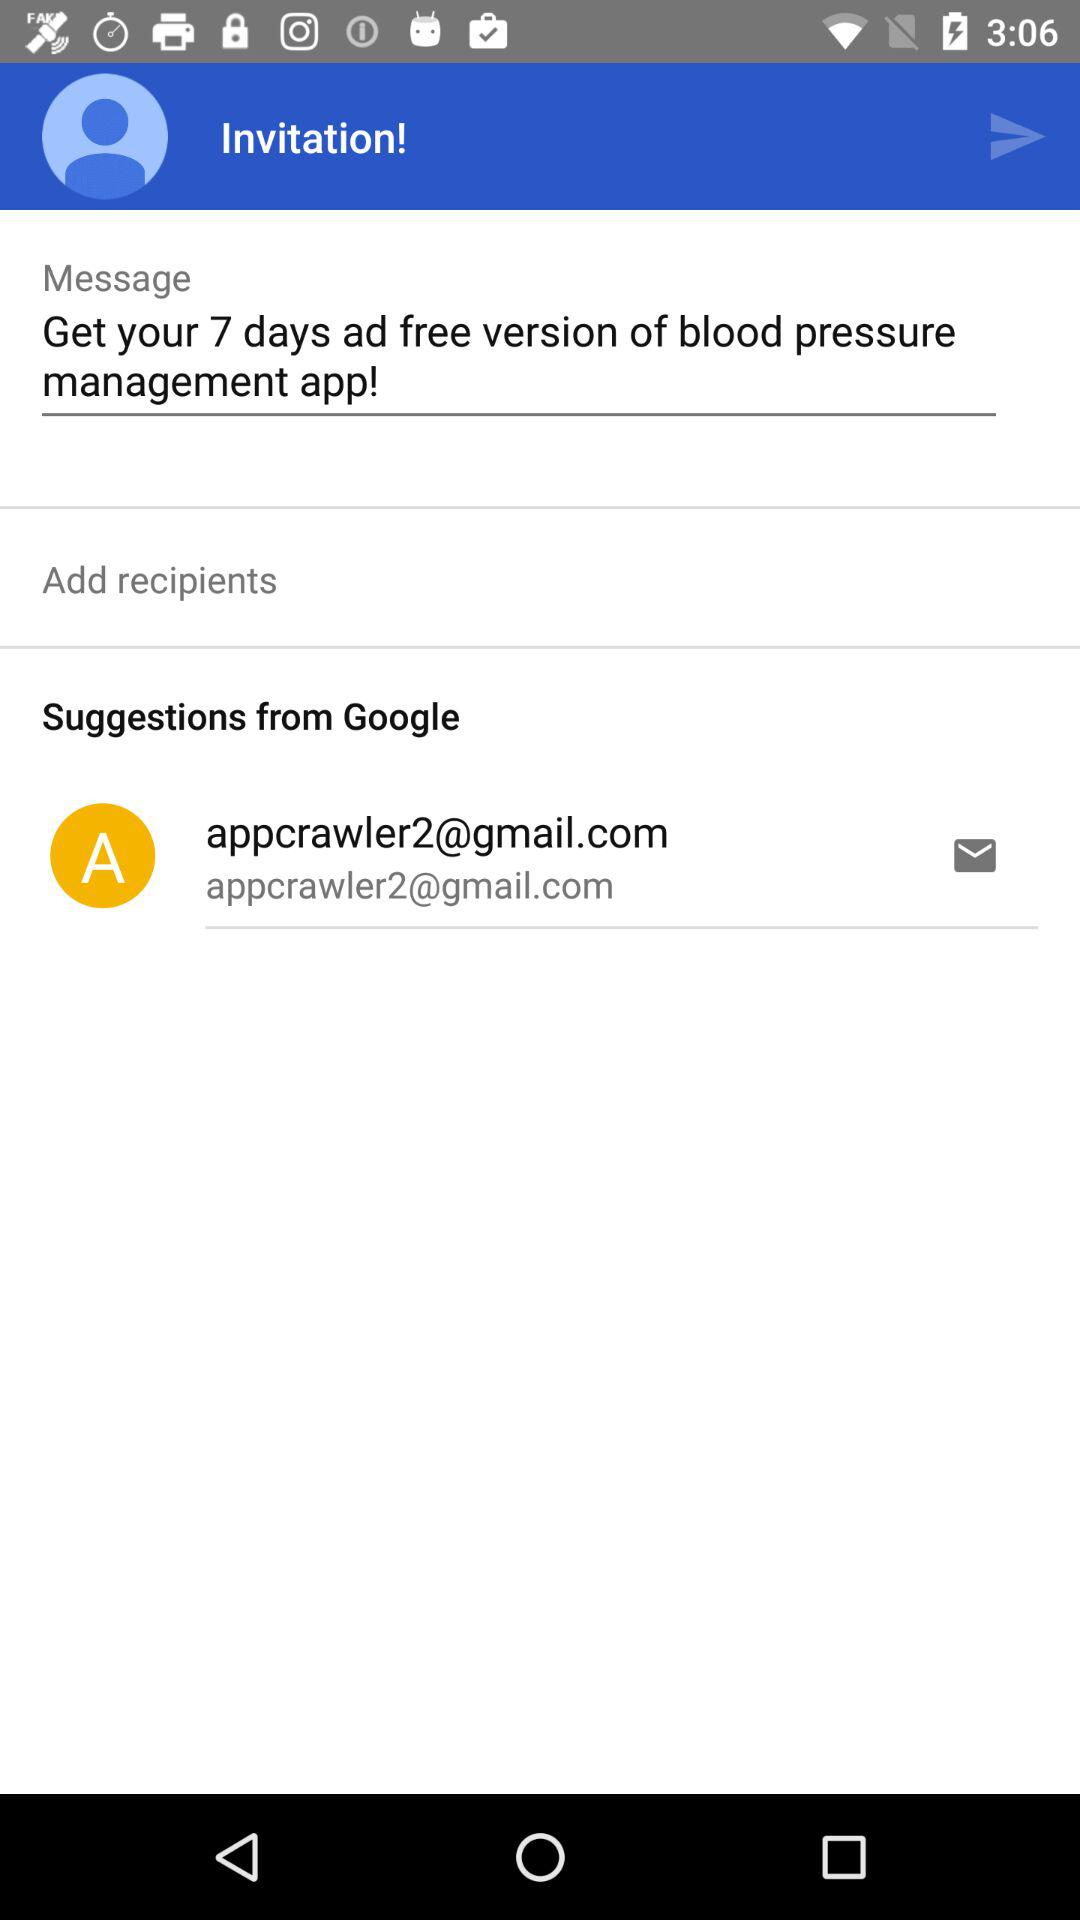What is the email address? The email address is appcrawler2@gmail.com. 